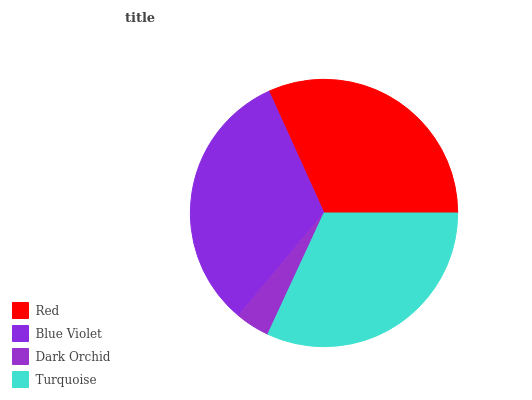Is Dark Orchid the minimum?
Answer yes or no. Yes. Is Blue Violet the maximum?
Answer yes or no. Yes. Is Blue Violet the minimum?
Answer yes or no. No. Is Dark Orchid the maximum?
Answer yes or no. No. Is Blue Violet greater than Dark Orchid?
Answer yes or no. Yes. Is Dark Orchid less than Blue Violet?
Answer yes or no. Yes. Is Dark Orchid greater than Blue Violet?
Answer yes or no. No. Is Blue Violet less than Dark Orchid?
Answer yes or no. No. Is Turquoise the high median?
Answer yes or no. Yes. Is Red the low median?
Answer yes or no. Yes. Is Blue Violet the high median?
Answer yes or no. No. Is Blue Violet the low median?
Answer yes or no. No. 